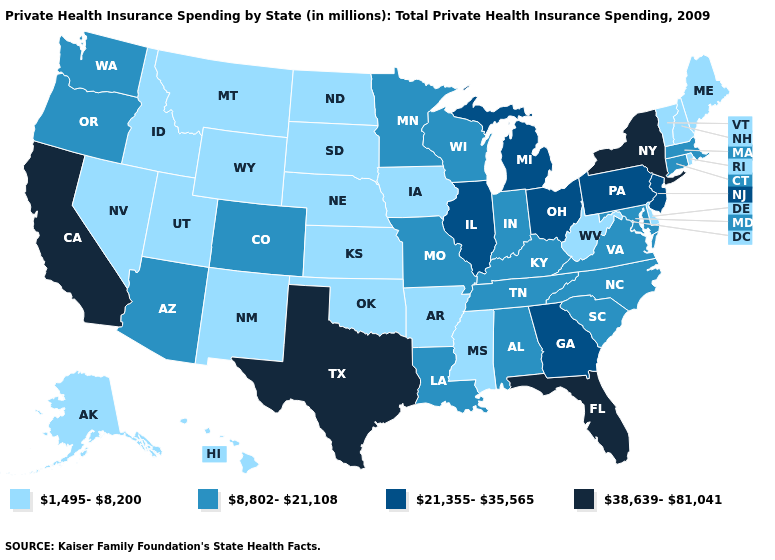What is the value of Tennessee?
Be succinct. 8,802-21,108. Name the states that have a value in the range 1,495-8,200?
Answer briefly. Alaska, Arkansas, Delaware, Hawaii, Idaho, Iowa, Kansas, Maine, Mississippi, Montana, Nebraska, Nevada, New Hampshire, New Mexico, North Dakota, Oklahoma, Rhode Island, South Dakota, Utah, Vermont, West Virginia, Wyoming. What is the highest value in states that border North Carolina?
Concise answer only. 21,355-35,565. Name the states that have a value in the range 8,802-21,108?
Write a very short answer. Alabama, Arizona, Colorado, Connecticut, Indiana, Kentucky, Louisiana, Maryland, Massachusetts, Minnesota, Missouri, North Carolina, Oregon, South Carolina, Tennessee, Virginia, Washington, Wisconsin. Does Texas have the highest value in the USA?
Quick response, please. Yes. What is the highest value in states that border North Carolina?
Quick response, please. 21,355-35,565. What is the value of New Mexico?
Quick response, please. 1,495-8,200. How many symbols are there in the legend?
Keep it brief. 4. What is the highest value in the West ?
Quick response, please. 38,639-81,041. Name the states that have a value in the range 38,639-81,041?
Write a very short answer. California, Florida, New York, Texas. Which states have the lowest value in the USA?
Keep it brief. Alaska, Arkansas, Delaware, Hawaii, Idaho, Iowa, Kansas, Maine, Mississippi, Montana, Nebraska, Nevada, New Hampshire, New Mexico, North Dakota, Oklahoma, Rhode Island, South Dakota, Utah, Vermont, West Virginia, Wyoming. Does Nevada have the lowest value in the USA?
Keep it brief. Yes. Does Mississippi have the lowest value in the South?
Be succinct. Yes. What is the lowest value in the West?
Give a very brief answer. 1,495-8,200. Which states have the highest value in the USA?
Keep it brief. California, Florida, New York, Texas. 